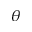<formula> <loc_0><loc_0><loc_500><loc_500>\theta</formula> 